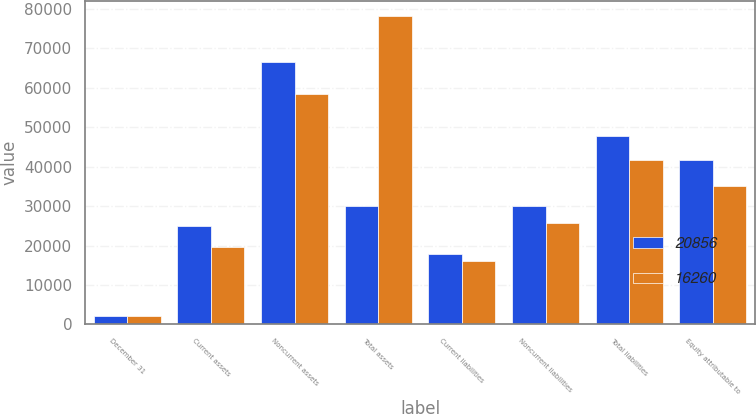Convert chart to OTSL. <chart><loc_0><loc_0><loc_500><loc_500><stacked_bar_chart><ecel><fcel>December 31<fcel>Current assets<fcel>Noncurrent assets<fcel>Total assets<fcel>Current liabilities<fcel>Noncurrent liabilities<fcel>Total liabilities<fcel>Equity attributable to<nl><fcel>20856<fcel>2017<fcel>25023<fcel>66578<fcel>29986<fcel>17890<fcel>29986<fcel>47876<fcel>41773<nl><fcel>16260<fcel>2016<fcel>19586<fcel>58529<fcel>78115<fcel>16125<fcel>25610<fcel>41735<fcel>35204<nl></chart> 